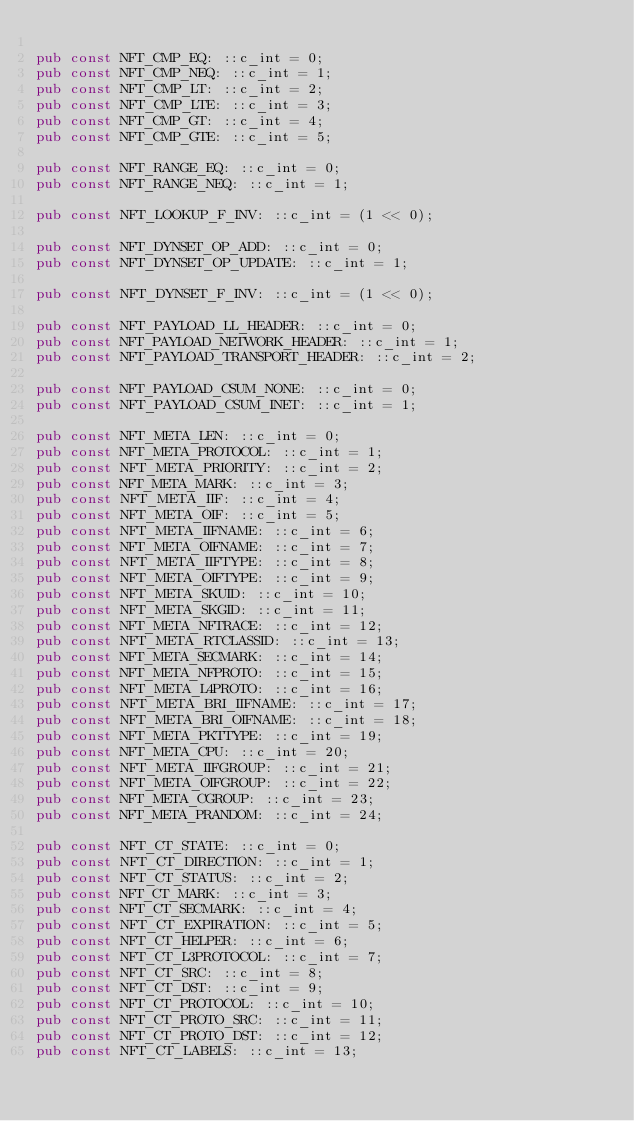Convert code to text. <code><loc_0><loc_0><loc_500><loc_500><_Rust_>
pub const NFT_CMP_EQ: ::c_int = 0;
pub const NFT_CMP_NEQ: ::c_int = 1;
pub const NFT_CMP_LT: ::c_int = 2;
pub const NFT_CMP_LTE: ::c_int = 3;
pub const NFT_CMP_GT: ::c_int = 4;
pub const NFT_CMP_GTE: ::c_int = 5;

pub const NFT_RANGE_EQ: ::c_int = 0;
pub const NFT_RANGE_NEQ: ::c_int = 1;

pub const NFT_LOOKUP_F_INV: ::c_int = (1 << 0);

pub const NFT_DYNSET_OP_ADD: ::c_int = 0;
pub const NFT_DYNSET_OP_UPDATE: ::c_int = 1;

pub const NFT_DYNSET_F_INV: ::c_int = (1 << 0);

pub const NFT_PAYLOAD_LL_HEADER: ::c_int = 0;
pub const NFT_PAYLOAD_NETWORK_HEADER: ::c_int = 1;
pub const NFT_PAYLOAD_TRANSPORT_HEADER: ::c_int = 2;

pub const NFT_PAYLOAD_CSUM_NONE: ::c_int = 0;
pub const NFT_PAYLOAD_CSUM_INET: ::c_int = 1;

pub const NFT_META_LEN: ::c_int = 0;
pub const NFT_META_PROTOCOL: ::c_int = 1;
pub const NFT_META_PRIORITY: ::c_int = 2;
pub const NFT_META_MARK: ::c_int = 3;
pub const NFT_META_IIF: ::c_int = 4;
pub const NFT_META_OIF: ::c_int = 5;
pub const NFT_META_IIFNAME: ::c_int = 6;
pub const NFT_META_OIFNAME: ::c_int = 7;
pub const NFT_META_IIFTYPE: ::c_int = 8;
pub const NFT_META_OIFTYPE: ::c_int = 9;
pub const NFT_META_SKUID: ::c_int = 10;
pub const NFT_META_SKGID: ::c_int = 11;
pub const NFT_META_NFTRACE: ::c_int = 12;
pub const NFT_META_RTCLASSID: ::c_int = 13;
pub const NFT_META_SECMARK: ::c_int = 14;
pub const NFT_META_NFPROTO: ::c_int = 15;
pub const NFT_META_L4PROTO: ::c_int = 16;
pub const NFT_META_BRI_IIFNAME: ::c_int = 17;
pub const NFT_META_BRI_OIFNAME: ::c_int = 18;
pub const NFT_META_PKTTYPE: ::c_int = 19;
pub const NFT_META_CPU: ::c_int = 20;
pub const NFT_META_IIFGROUP: ::c_int = 21;
pub const NFT_META_OIFGROUP: ::c_int = 22;
pub const NFT_META_CGROUP: ::c_int = 23;
pub const NFT_META_PRANDOM: ::c_int = 24;

pub const NFT_CT_STATE: ::c_int = 0;
pub const NFT_CT_DIRECTION: ::c_int = 1;
pub const NFT_CT_STATUS: ::c_int = 2;
pub const NFT_CT_MARK: ::c_int = 3;
pub const NFT_CT_SECMARK: ::c_int = 4;
pub const NFT_CT_EXPIRATION: ::c_int = 5;
pub const NFT_CT_HELPER: ::c_int = 6;
pub const NFT_CT_L3PROTOCOL: ::c_int = 7;
pub const NFT_CT_SRC: ::c_int = 8;
pub const NFT_CT_DST: ::c_int = 9;
pub const NFT_CT_PROTOCOL: ::c_int = 10;
pub const NFT_CT_PROTO_SRC: ::c_int = 11;
pub const NFT_CT_PROTO_DST: ::c_int = 12;
pub const NFT_CT_LABELS: ::c_int = 13;</code> 